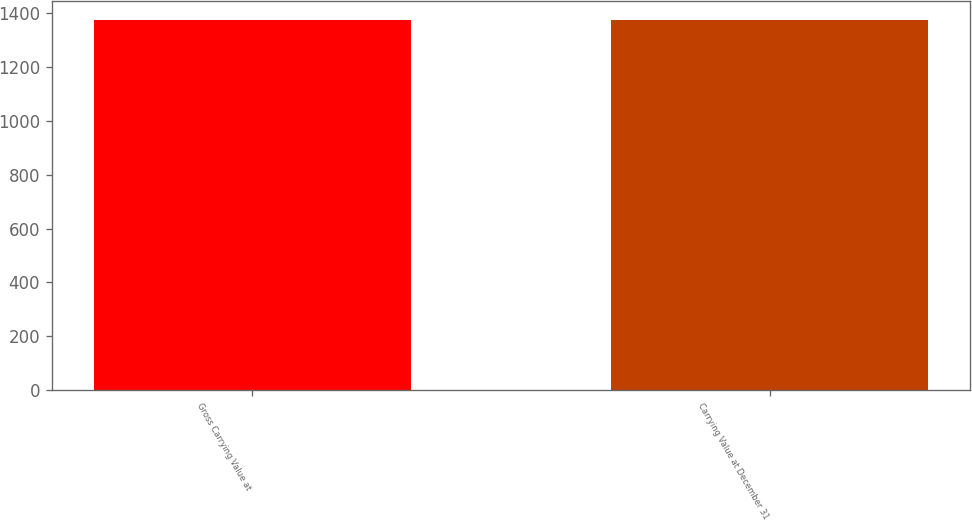Convert chart to OTSL. <chart><loc_0><loc_0><loc_500><loc_500><bar_chart><fcel>Gross Carrying Value at<fcel>Carrying Value at December 31<nl><fcel>1373.7<fcel>1373.95<nl></chart> 